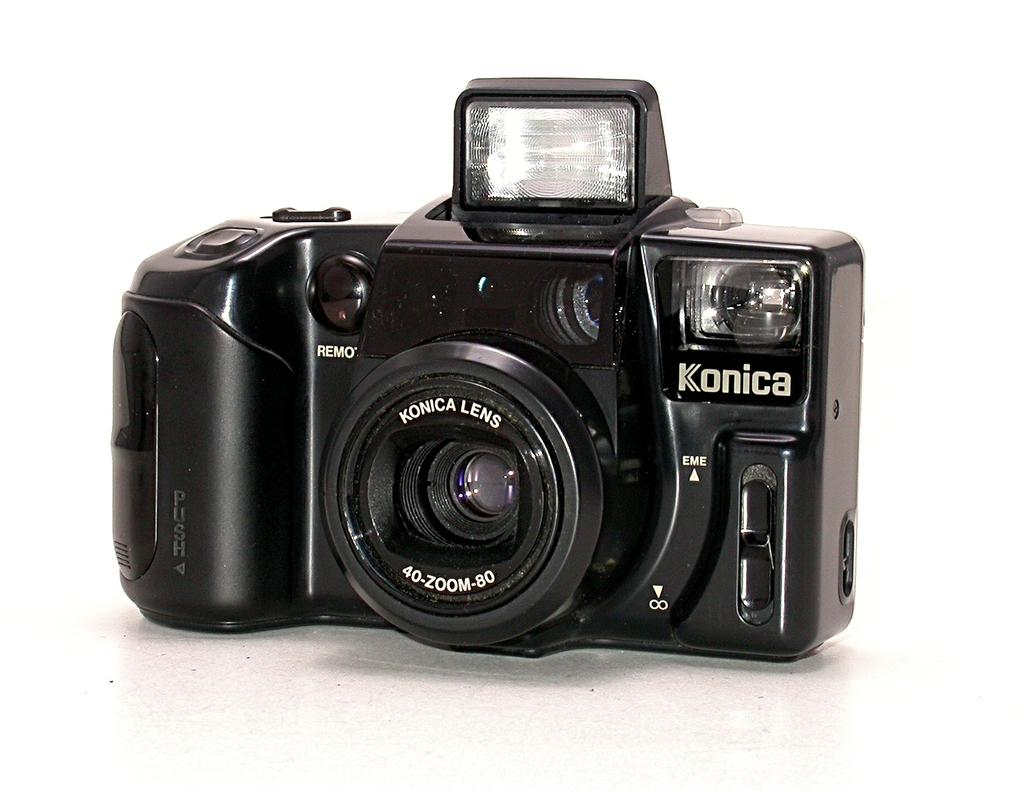What is the main subject of the image? The main subject of the image is a digital camera. What is the aftermath of the dock in the image? There is no dock present in the image, and therefore no aftermath can be observed. 